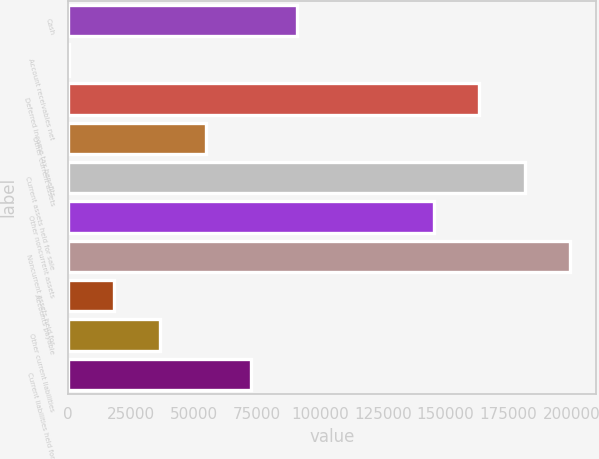<chart> <loc_0><loc_0><loc_500><loc_500><bar_chart><fcel>Cash<fcel>Account receivables net<fcel>Deferred income tax benefits<fcel>Other current assets<fcel>Current assets held for sale<fcel>Other noncurrent assets<fcel>Noncurrent assets held for<fcel>Accounts payable<fcel>Other current liabilities<fcel>Current liabilities held for<nl><fcel>90832.5<fcel>209<fcel>163331<fcel>54583.1<fcel>181456<fcel>145207<fcel>199581<fcel>18333.7<fcel>36458.4<fcel>72707.8<nl></chart> 